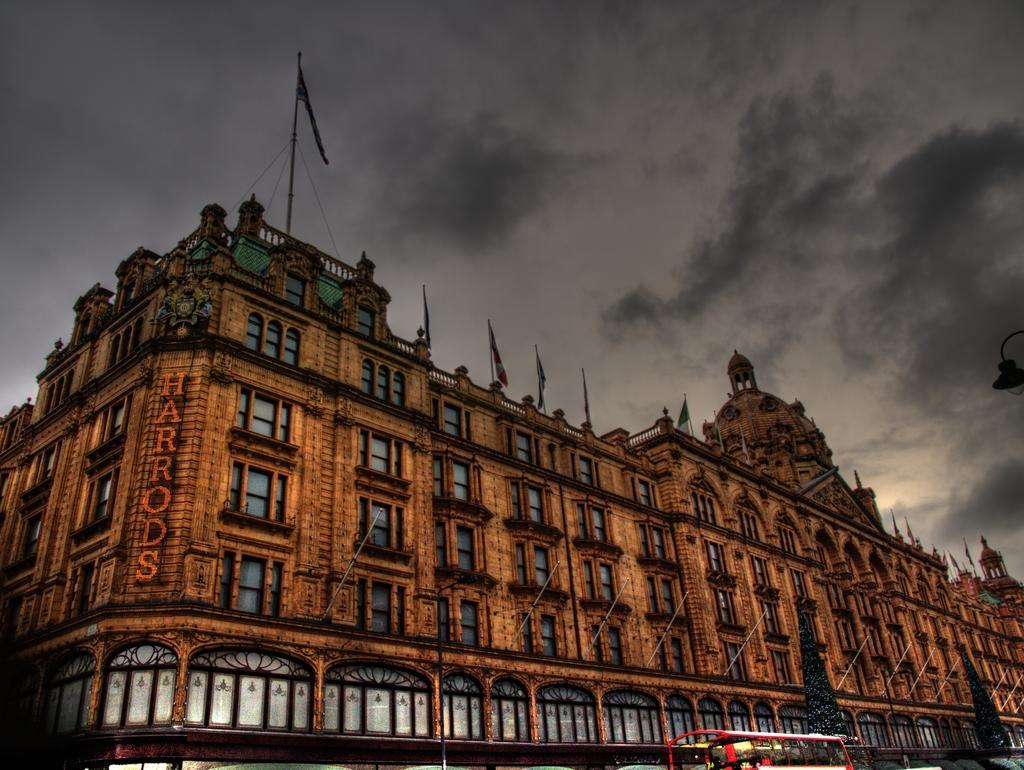Could you give a brief overview of what you see in this image? In the picture we can see a historical palace on it, we can see the windows and on the top of it, we can see railings, flags to the poles and on the building we can see a name HARRODS on it and in the background, we can see a sky with clouds and near to the building we can see two tall trees and a bus which is red in color. 